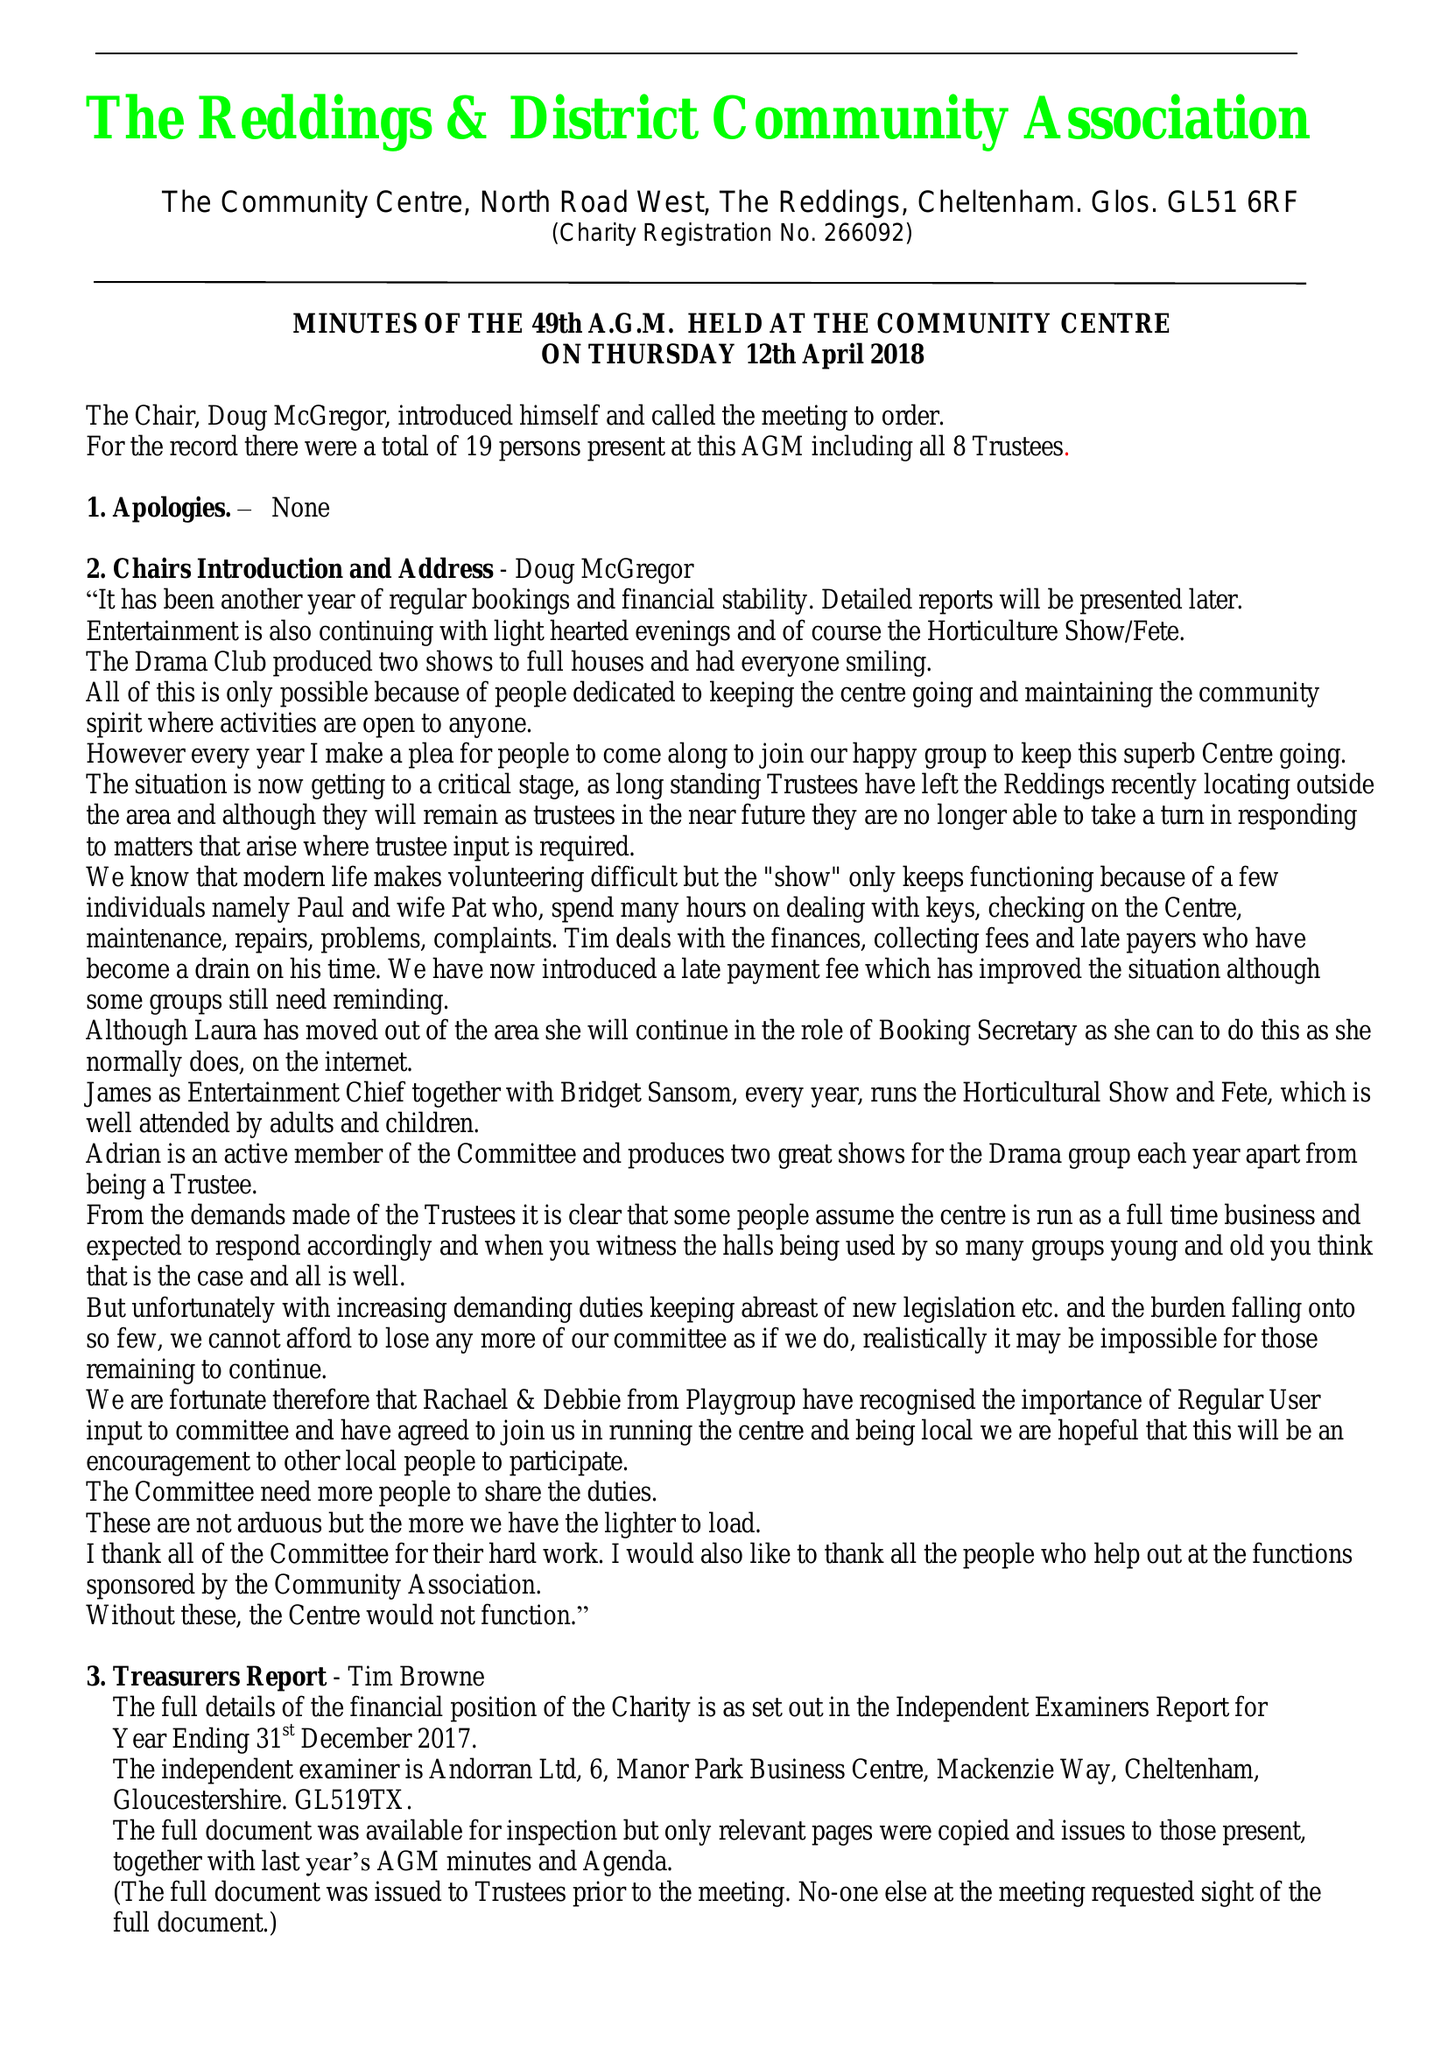What is the value for the charity_name?
Answer the question using a single word or phrase. Reddings and District Community Association 